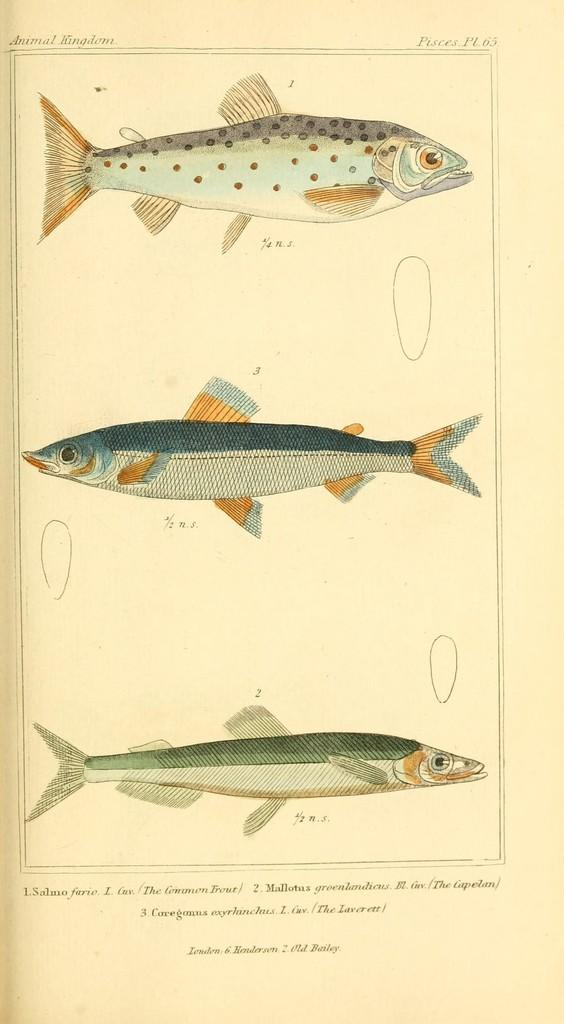What is depicted on the page in the image? There is a diagram of fishes on the page. What else can be found on the page besides the diagram of fishes? There is text written on the page. How does the hen interact with the diagram of fishes on the page? There is no hen present in the image, so it cannot interact with the diagram of fishes. 